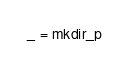<code> <loc_0><loc_0><loc_500><loc_500><_Python_>_ = mkdir_p
</code> 